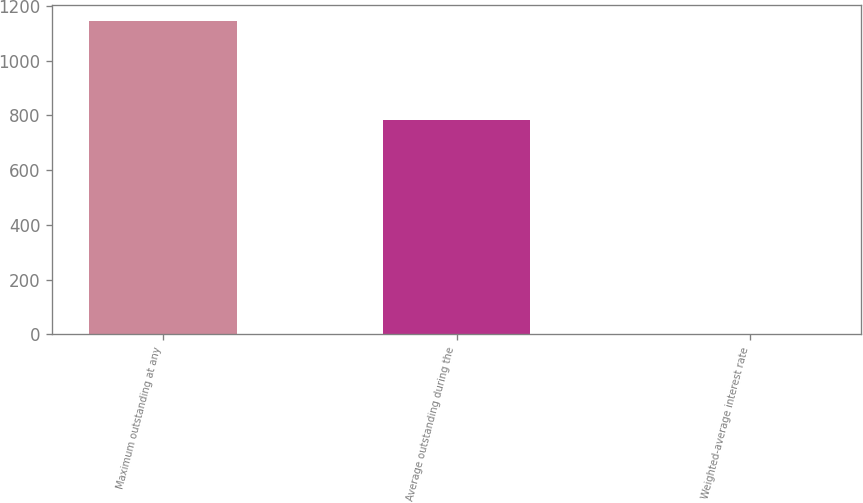Convert chart to OTSL. <chart><loc_0><loc_0><loc_500><loc_500><bar_chart><fcel>Maximum outstanding at any<fcel>Average outstanding during the<fcel>Weighted-average interest rate<nl><fcel>1145<fcel>784<fcel>0.09<nl></chart> 